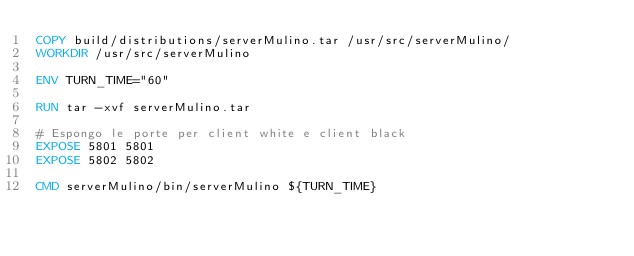Convert code to text. <code><loc_0><loc_0><loc_500><loc_500><_Dockerfile_>COPY build/distributions/serverMulino.tar /usr/src/serverMulino/
WORKDIR /usr/src/serverMulino

ENV TURN_TIME="60"

RUN tar -xvf serverMulino.tar

# Espongo le porte per client white e client black
EXPOSE 5801 5801
EXPOSE 5802 5802

CMD serverMulino/bin/serverMulino ${TURN_TIME}
</code> 